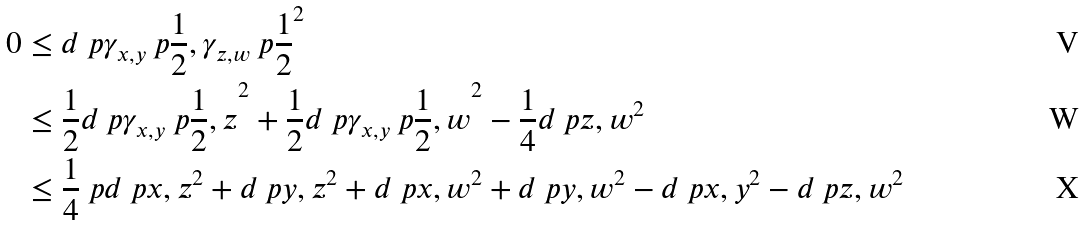Convert formula to latex. <formula><loc_0><loc_0><loc_500><loc_500>0 & \leq d \ p { \gamma _ { x , y } \ p { \frac { 1 } { 2 } } , \gamma _ { z , w } \ p { \frac { 1 } { 2 } } } ^ { 2 } \\ & \leq \frac { 1 } { 2 } d \ p { \gamma _ { x , y } \ p { \frac { 1 } { 2 } } , z } ^ { 2 } + \frac { 1 } { 2 } d \ p { \gamma _ { x , y } \ p { \frac { 1 } { 2 } } , w } ^ { 2 } - \frac { 1 } { 4 } d \ p { z , w } ^ { 2 } \\ & \leq \frac { 1 } { 4 } \ p { d \ p { x , z } ^ { 2 } + d \ p { y , z } ^ { 2 } + d \ p { x , w } ^ { 2 } + d \ p { y , w } ^ { 2 } - d \ p { x , y } ^ { 2 } - d \ p { z , w } ^ { 2 } }</formula> 